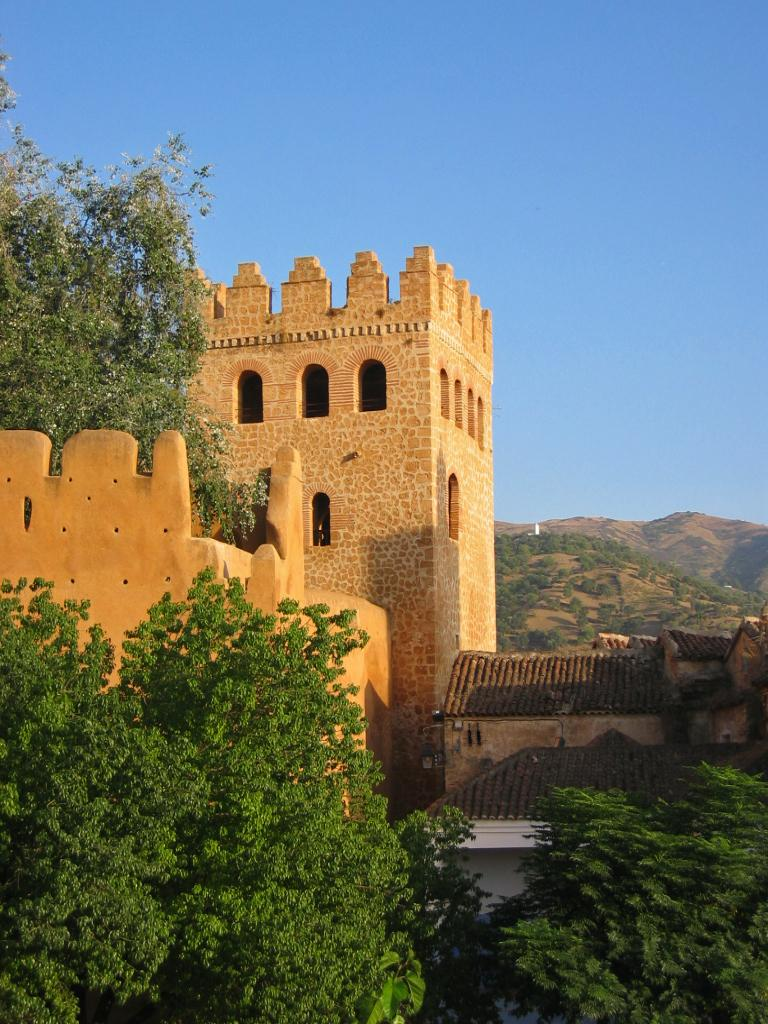What type of structures can be seen in the image? There are buildings in the image. What natural elements are present in the image? There are trees and mountains in the image. What is visible in the background of the image? The sky is visible in the background of the image. Can you tell me how many cubs are playing with an umbrella in the image? There are no cubs or umbrellas present in the image. What type of support is provided by the trees in the image? The trees in the image do not provide any visible support; they are natural elements in the landscape. 